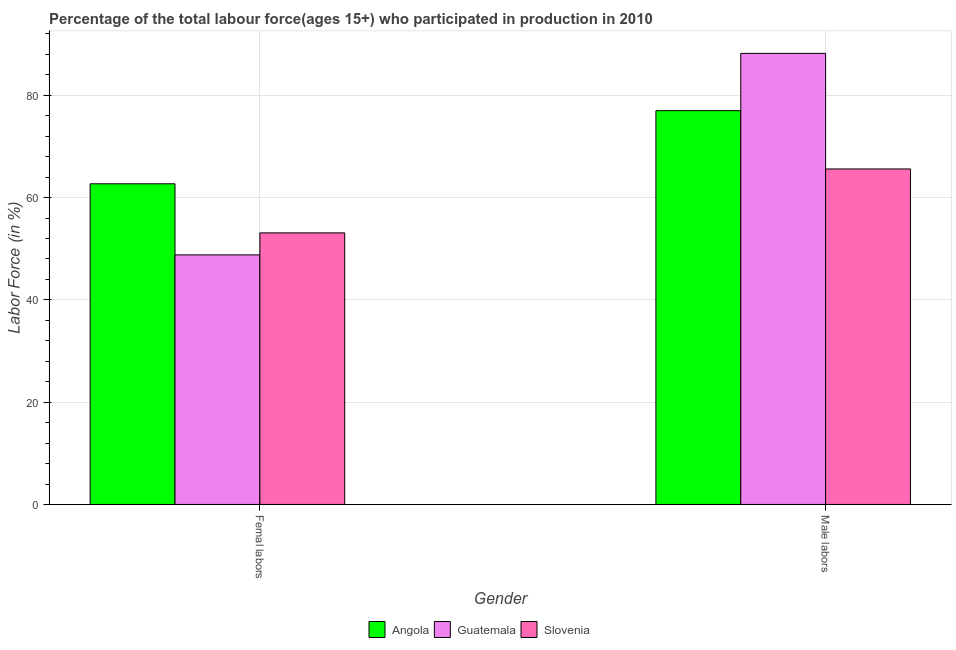How many different coloured bars are there?
Offer a very short reply. 3. How many groups of bars are there?
Give a very brief answer. 2. Are the number of bars per tick equal to the number of legend labels?
Offer a terse response. Yes. Are the number of bars on each tick of the X-axis equal?
Offer a terse response. Yes. What is the label of the 2nd group of bars from the left?
Your answer should be compact. Male labors. What is the percentage of female labor force in Guatemala?
Your answer should be compact. 48.8. Across all countries, what is the maximum percentage of male labour force?
Provide a succinct answer. 88.2. Across all countries, what is the minimum percentage of male labour force?
Your answer should be very brief. 65.6. In which country was the percentage of female labor force maximum?
Give a very brief answer. Angola. In which country was the percentage of female labor force minimum?
Give a very brief answer. Guatemala. What is the total percentage of female labor force in the graph?
Give a very brief answer. 164.6. What is the difference between the percentage of female labor force in Guatemala and that in Angola?
Make the answer very short. -13.9. What is the difference between the percentage of male labour force in Guatemala and the percentage of female labor force in Angola?
Your answer should be very brief. 25.5. What is the average percentage of female labor force per country?
Your answer should be compact. 54.87. What is the difference between the percentage of male labour force and percentage of female labor force in Guatemala?
Offer a terse response. 39.4. In how many countries, is the percentage of male labour force greater than 28 %?
Offer a very short reply. 3. What is the ratio of the percentage of male labour force in Slovenia to that in Guatemala?
Give a very brief answer. 0.74. What does the 3rd bar from the left in Male labors represents?
Your response must be concise. Slovenia. What does the 2nd bar from the right in Femal labors represents?
Ensure brevity in your answer.  Guatemala. How many bars are there?
Keep it short and to the point. 6. What is the difference between two consecutive major ticks on the Y-axis?
Keep it short and to the point. 20. Are the values on the major ticks of Y-axis written in scientific E-notation?
Offer a very short reply. No. Does the graph contain any zero values?
Your answer should be compact. No. How are the legend labels stacked?
Your answer should be very brief. Horizontal. What is the title of the graph?
Make the answer very short. Percentage of the total labour force(ages 15+) who participated in production in 2010. What is the label or title of the Y-axis?
Provide a short and direct response. Labor Force (in %). What is the Labor Force (in %) of Angola in Femal labors?
Your answer should be compact. 62.7. What is the Labor Force (in %) in Guatemala in Femal labors?
Your response must be concise. 48.8. What is the Labor Force (in %) of Slovenia in Femal labors?
Offer a terse response. 53.1. What is the Labor Force (in %) of Angola in Male labors?
Keep it short and to the point. 77. What is the Labor Force (in %) in Guatemala in Male labors?
Offer a very short reply. 88.2. What is the Labor Force (in %) in Slovenia in Male labors?
Your response must be concise. 65.6. Across all Gender, what is the maximum Labor Force (in %) of Guatemala?
Provide a short and direct response. 88.2. Across all Gender, what is the maximum Labor Force (in %) in Slovenia?
Provide a succinct answer. 65.6. Across all Gender, what is the minimum Labor Force (in %) of Angola?
Keep it short and to the point. 62.7. Across all Gender, what is the minimum Labor Force (in %) in Guatemala?
Give a very brief answer. 48.8. Across all Gender, what is the minimum Labor Force (in %) in Slovenia?
Ensure brevity in your answer.  53.1. What is the total Labor Force (in %) of Angola in the graph?
Your response must be concise. 139.7. What is the total Labor Force (in %) of Guatemala in the graph?
Make the answer very short. 137. What is the total Labor Force (in %) of Slovenia in the graph?
Your answer should be very brief. 118.7. What is the difference between the Labor Force (in %) in Angola in Femal labors and that in Male labors?
Ensure brevity in your answer.  -14.3. What is the difference between the Labor Force (in %) of Guatemala in Femal labors and that in Male labors?
Ensure brevity in your answer.  -39.4. What is the difference between the Labor Force (in %) in Slovenia in Femal labors and that in Male labors?
Give a very brief answer. -12.5. What is the difference between the Labor Force (in %) of Angola in Femal labors and the Labor Force (in %) of Guatemala in Male labors?
Provide a short and direct response. -25.5. What is the difference between the Labor Force (in %) of Angola in Femal labors and the Labor Force (in %) of Slovenia in Male labors?
Offer a very short reply. -2.9. What is the difference between the Labor Force (in %) in Guatemala in Femal labors and the Labor Force (in %) in Slovenia in Male labors?
Ensure brevity in your answer.  -16.8. What is the average Labor Force (in %) of Angola per Gender?
Provide a short and direct response. 69.85. What is the average Labor Force (in %) in Guatemala per Gender?
Your answer should be compact. 68.5. What is the average Labor Force (in %) in Slovenia per Gender?
Your answer should be compact. 59.35. What is the difference between the Labor Force (in %) of Guatemala and Labor Force (in %) of Slovenia in Femal labors?
Give a very brief answer. -4.3. What is the difference between the Labor Force (in %) of Angola and Labor Force (in %) of Guatemala in Male labors?
Ensure brevity in your answer.  -11.2. What is the difference between the Labor Force (in %) in Guatemala and Labor Force (in %) in Slovenia in Male labors?
Your answer should be compact. 22.6. What is the ratio of the Labor Force (in %) in Angola in Femal labors to that in Male labors?
Give a very brief answer. 0.81. What is the ratio of the Labor Force (in %) in Guatemala in Femal labors to that in Male labors?
Provide a succinct answer. 0.55. What is the ratio of the Labor Force (in %) of Slovenia in Femal labors to that in Male labors?
Offer a very short reply. 0.81. What is the difference between the highest and the second highest Labor Force (in %) of Angola?
Keep it short and to the point. 14.3. What is the difference between the highest and the second highest Labor Force (in %) in Guatemala?
Offer a terse response. 39.4. What is the difference between the highest and the second highest Labor Force (in %) of Slovenia?
Your answer should be very brief. 12.5. What is the difference between the highest and the lowest Labor Force (in %) in Angola?
Provide a short and direct response. 14.3. What is the difference between the highest and the lowest Labor Force (in %) of Guatemala?
Make the answer very short. 39.4. What is the difference between the highest and the lowest Labor Force (in %) of Slovenia?
Your response must be concise. 12.5. 